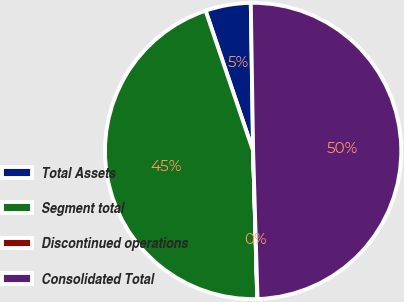Convert chart. <chart><loc_0><loc_0><loc_500><loc_500><pie_chart><fcel>Total Assets<fcel>Segment total<fcel>Discontinued operations<fcel>Consolidated Total<nl><fcel>4.95%<fcel>45.25%<fcel>0.03%<fcel>49.78%<nl></chart> 